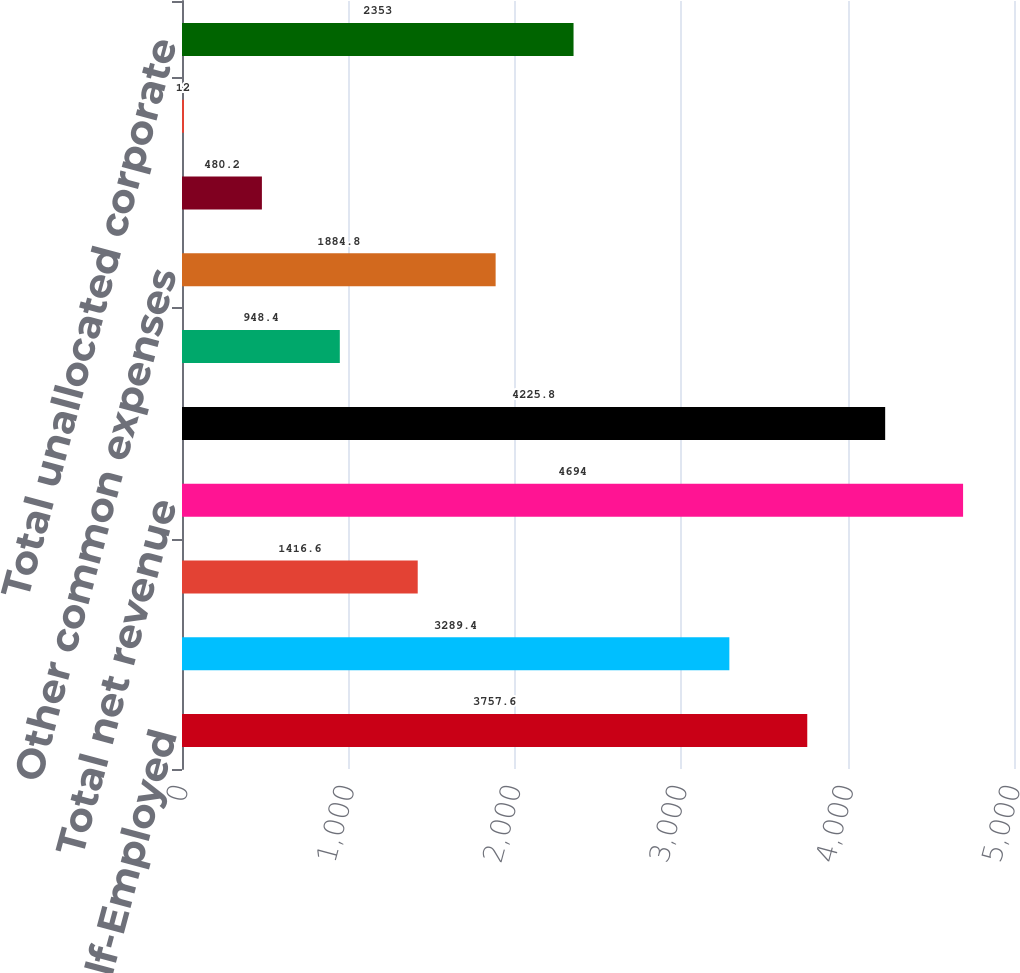<chart> <loc_0><loc_0><loc_500><loc_500><bar_chart><fcel>Small Business & Self-Employed<fcel>Consumer<fcel>Strategic Partner<fcel>Total net revenue<fcel>Total segment operating income<fcel>Share-based compensation<fcel>Other common expenses<fcel>Amortization of acquired<fcel>Amortization of other acquired<fcel>Total unallocated corporate<nl><fcel>3757.6<fcel>3289.4<fcel>1416.6<fcel>4694<fcel>4225.8<fcel>948.4<fcel>1884.8<fcel>480.2<fcel>12<fcel>2353<nl></chart> 